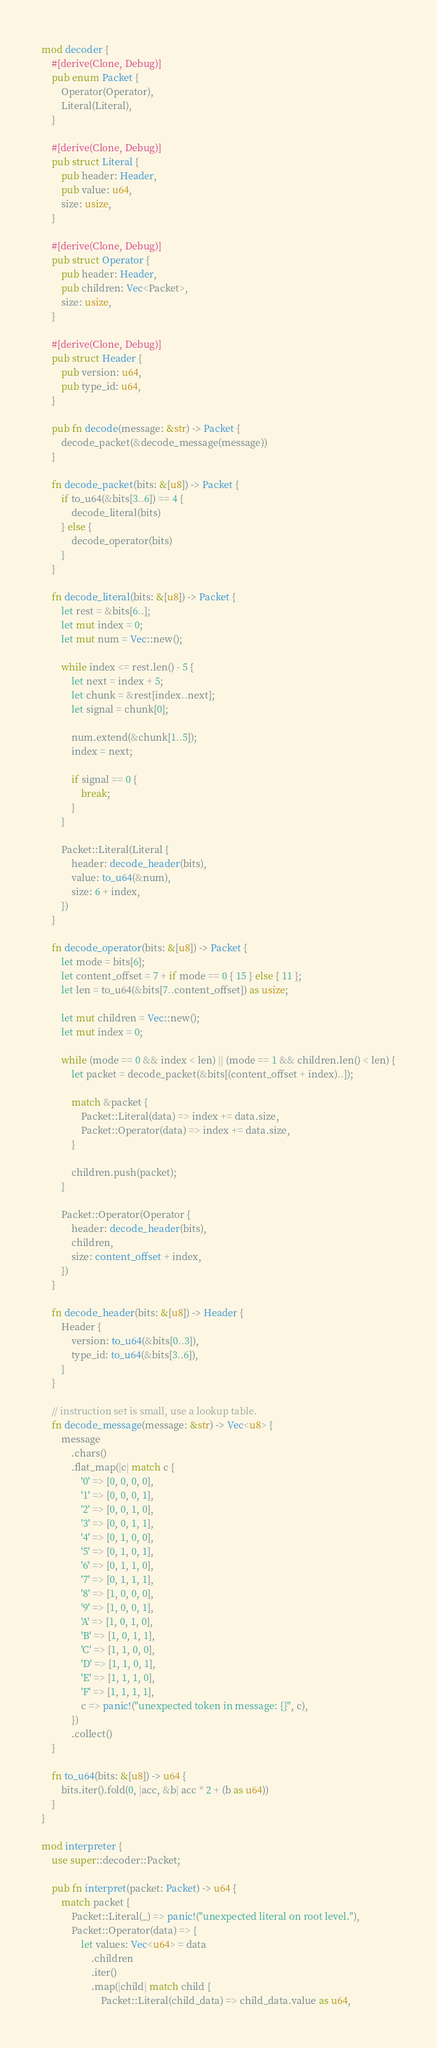<code> <loc_0><loc_0><loc_500><loc_500><_Rust_>mod decoder {
    #[derive(Clone, Debug)]
    pub enum Packet {
        Operator(Operator),
        Literal(Literal),
    }

    #[derive(Clone, Debug)]
    pub struct Literal {
        pub header: Header,
        pub value: u64,
        size: usize,
    }

    #[derive(Clone, Debug)]
    pub struct Operator {
        pub header: Header,
        pub children: Vec<Packet>,
        size: usize,
    }

    #[derive(Clone, Debug)]
    pub struct Header {
        pub version: u64,
        pub type_id: u64,
    }

    pub fn decode(message: &str) -> Packet {
        decode_packet(&decode_message(message))
    }

    fn decode_packet(bits: &[u8]) -> Packet {
        if to_u64(&bits[3..6]) == 4 {
            decode_literal(bits)
        } else {
            decode_operator(bits)
        }
    }

    fn decode_literal(bits: &[u8]) -> Packet {
        let rest = &bits[6..];
        let mut index = 0;
        let mut num = Vec::new();

        while index <= rest.len() - 5 {
            let next = index + 5;
            let chunk = &rest[index..next];
            let signal = chunk[0];

            num.extend(&chunk[1..5]);
            index = next;

            if signal == 0 {
                break;
            }
        }

        Packet::Literal(Literal {
            header: decode_header(bits),
            value: to_u64(&num),
            size: 6 + index,
        })
    }

    fn decode_operator(bits: &[u8]) -> Packet {
        let mode = bits[6];
        let content_offset = 7 + if mode == 0 { 15 } else { 11 };
        let len = to_u64(&bits[7..content_offset]) as usize;

        let mut children = Vec::new();
        let mut index = 0;

        while (mode == 0 && index < len) || (mode == 1 && children.len() < len) {
            let packet = decode_packet(&bits[(content_offset + index)..]);

            match &packet {
                Packet::Literal(data) => index += data.size,
                Packet::Operator(data) => index += data.size,
            }

            children.push(packet);
        }

        Packet::Operator(Operator {
            header: decode_header(bits),
            children,
            size: content_offset + index,
        })
    }

    fn decode_header(bits: &[u8]) -> Header {
        Header {
            version: to_u64(&bits[0..3]),
            type_id: to_u64(&bits[3..6]),
        }
    }

    // instruction set is small, use a lookup table.
    fn decode_message(message: &str) -> Vec<u8> {
        message
            .chars()
            .flat_map(|c| match c {
                '0' => [0, 0, 0, 0],
                '1' => [0, 0, 0, 1],
                '2' => [0, 0, 1, 0],
                '3' => [0, 0, 1, 1],
                '4' => [0, 1, 0, 0],
                '5' => [0, 1, 0, 1],
                '6' => [0, 1, 1, 0],
                '7' => [0, 1, 1, 1],
                '8' => [1, 0, 0, 0],
                '9' => [1, 0, 0, 1],
                'A' => [1, 0, 1, 0],
                'B' => [1, 0, 1, 1],
                'C' => [1, 1, 0, 0],
                'D' => [1, 1, 0, 1],
                'E' => [1, 1, 1, 0],
                'F' => [1, 1, 1, 1],
                c => panic!("unexpected token in message: {}", c),
            })
            .collect()
    }

    fn to_u64(bits: &[u8]) -> u64 {
        bits.iter().fold(0, |acc, &b| acc * 2 + (b as u64))
    }
}

mod interpreter {
    use super::decoder::Packet;

    pub fn interpret(packet: Packet) -> u64 {
        match packet {
            Packet::Literal(_) => panic!("unexpected literal on root level."),
            Packet::Operator(data) => {
                let values: Vec<u64> = data
                    .children
                    .iter()
                    .map(|child| match child {
                        Packet::Literal(child_data) => child_data.value as u64,</code> 